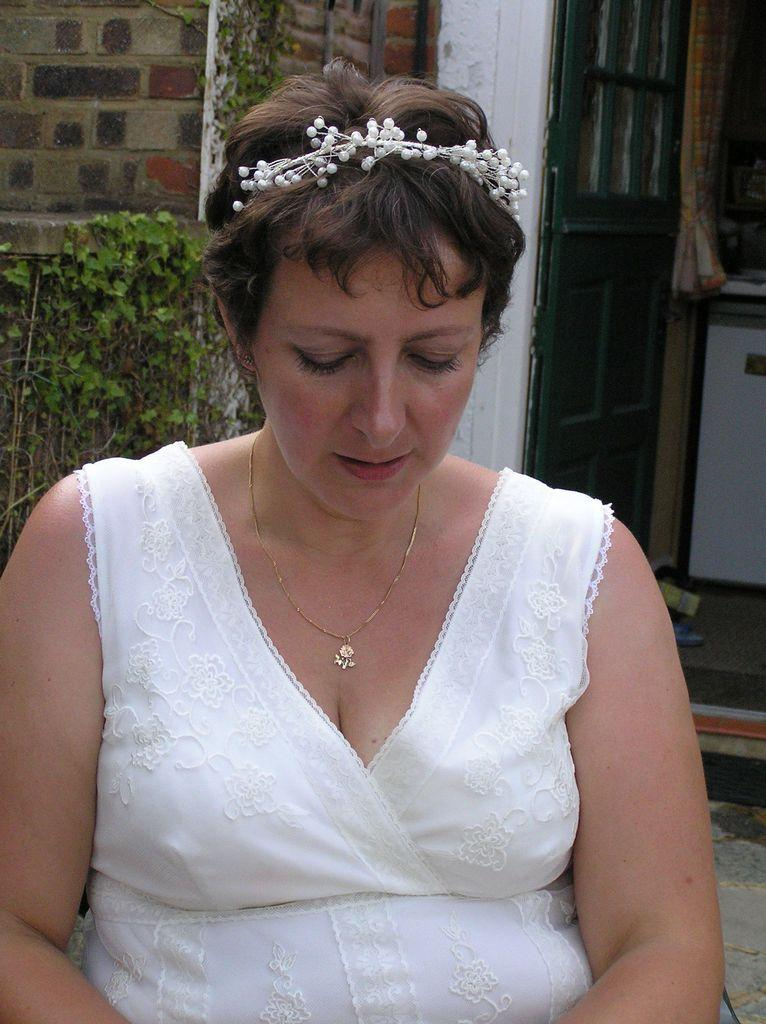Who is the main subject in the foreground of the image? There is a woman in the foreground of the image. What can be seen in the background of the image? There is a house, plants, a door, a curtain, and other objects in the background of the image. Can you describe the house in the background? The house is in the background of the image, but no specific details about its appearance are provided. What type of stick can be seen in the woman's hand in the image? There is no stick present in the woman's hand or anywhere else in the image. What kind of soap is being used to clean the curtain in the image? There is no soap or cleaning activity depicted in the image. 